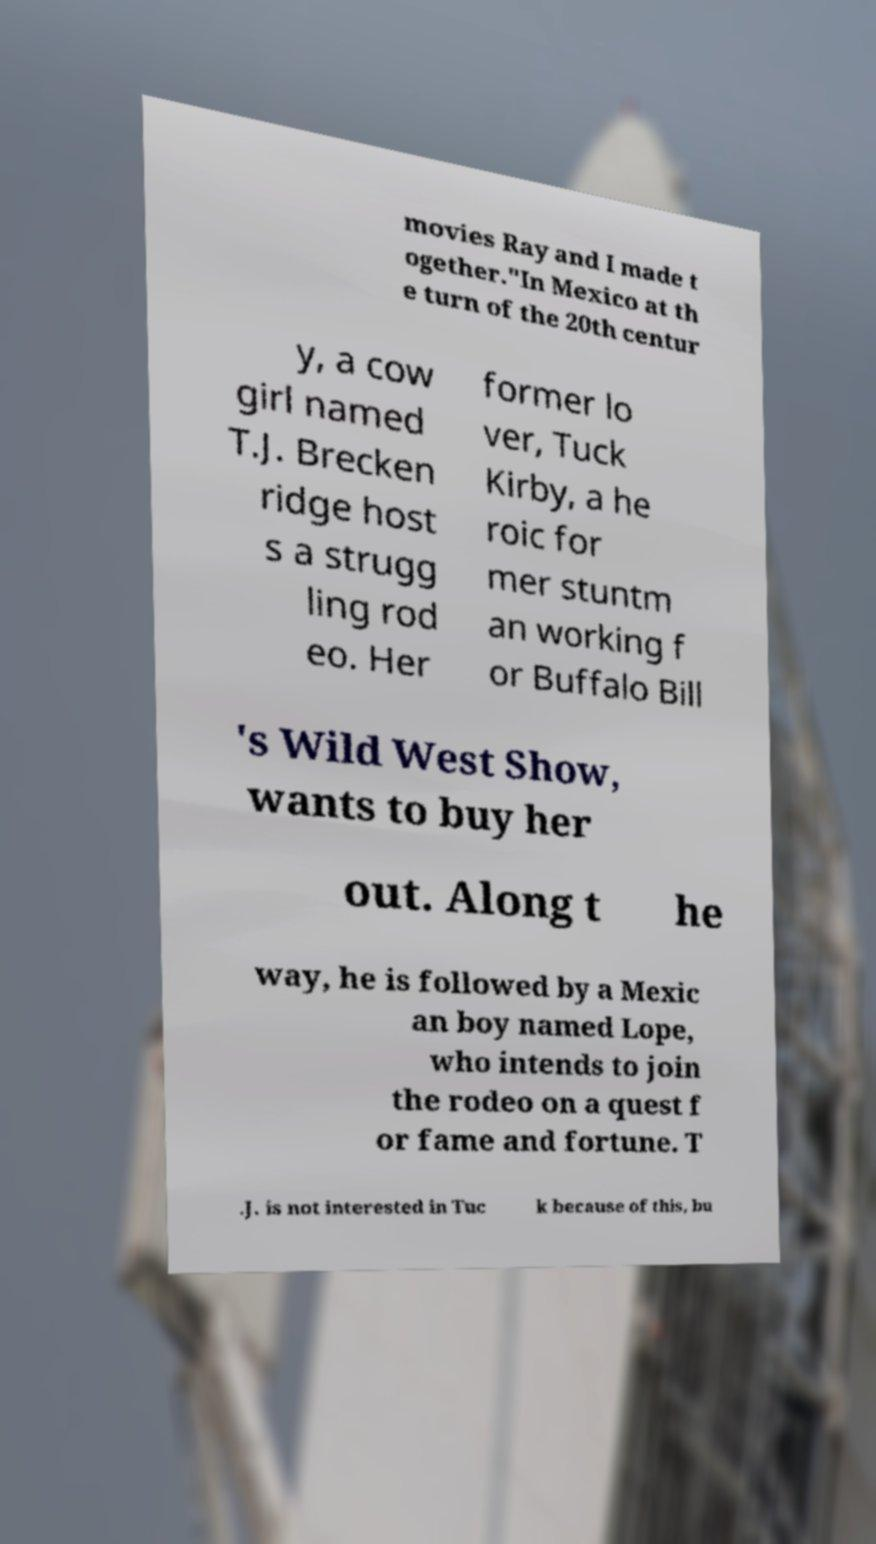Could you assist in decoding the text presented in this image and type it out clearly? movies Ray and I made t ogether."In Mexico at th e turn of the 20th centur y, a cow girl named T.J. Brecken ridge host s a strugg ling rod eo. Her former lo ver, Tuck Kirby, a he roic for mer stuntm an working f or Buffalo Bill 's Wild West Show, wants to buy her out. Along t he way, he is followed by a Mexic an boy named Lope, who intends to join the rodeo on a quest f or fame and fortune. T .J. is not interested in Tuc k because of this, bu 